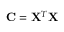Convert formula to latex. <formula><loc_0><loc_0><loc_500><loc_500>{ C = X ^ { T } X }</formula> 